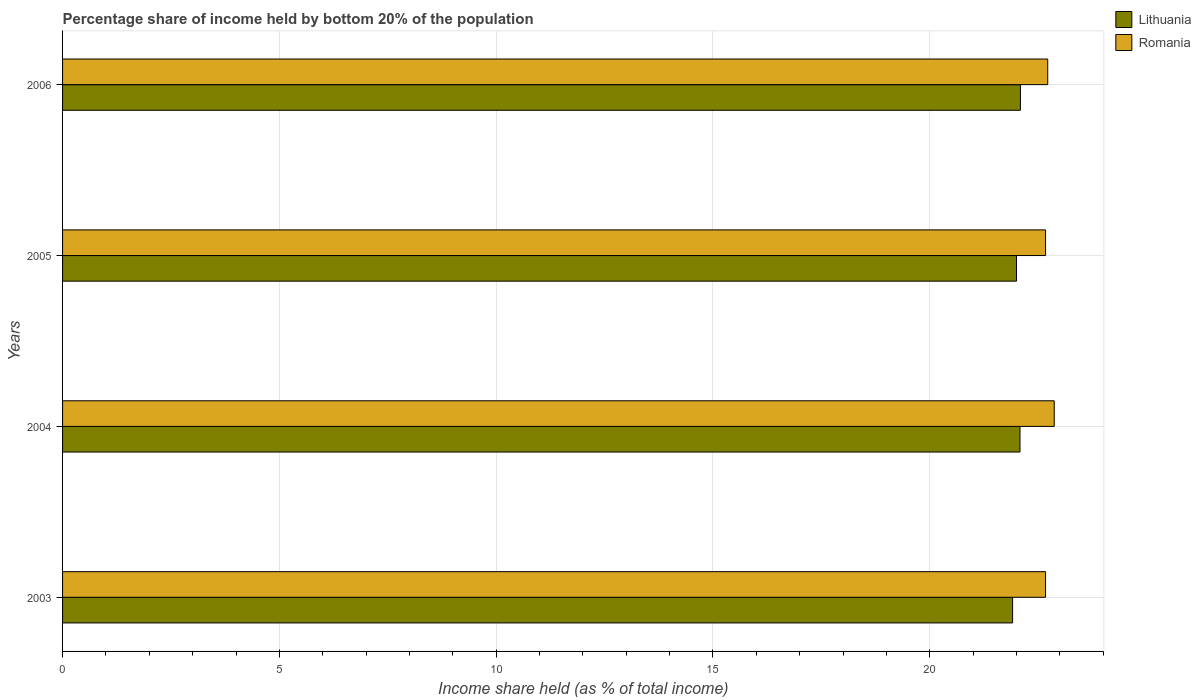Are the number of bars per tick equal to the number of legend labels?
Offer a terse response. Yes. Are the number of bars on each tick of the Y-axis equal?
Provide a succinct answer. Yes. How many bars are there on the 4th tick from the top?
Your response must be concise. 2. What is the share of income held by bottom 20% of the population in Romania in 2004?
Ensure brevity in your answer.  22.87. Across all years, what is the maximum share of income held by bottom 20% of the population in Romania?
Provide a succinct answer. 22.87. Across all years, what is the minimum share of income held by bottom 20% of the population in Romania?
Your answer should be very brief. 22.67. In which year was the share of income held by bottom 20% of the population in Lithuania maximum?
Offer a very short reply. 2006. In which year was the share of income held by bottom 20% of the population in Romania minimum?
Offer a terse response. 2003. What is the total share of income held by bottom 20% of the population in Lithuania in the graph?
Offer a terse response. 88.08. What is the difference between the share of income held by bottom 20% of the population in Lithuania in 2003 and that in 2006?
Offer a very short reply. -0.18. What is the difference between the share of income held by bottom 20% of the population in Romania in 2004 and the share of income held by bottom 20% of the population in Lithuania in 2006?
Give a very brief answer. 0.78. What is the average share of income held by bottom 20% of the population in Romania per year?
Your answer should be compact. 22.73. In the year 2003, what is the difference between the share of income held by bottom 20% of the population in Lithuania and share of income held by bottom 20% of the population in Romania?
Your answer should be very brief. -0.76. In how many years, is the share of income held by bottom 20% of the population in Lithuania greater than 1 %?
Your answer should be compact. 4. What is the ratio of the share of income held by bottom 20% of the population in Romania in 2005 to that in 2006?
Make the answer very short. 1. What is the difference between the highest and the second highest share of income held by bottom 20% of the population in Romania?
Give a very brief answer. 0.15. What is the difference between the highest and the lowest share of income held by bottom 20% of the population in Lithuania?
Provide a short and direct response. 0.18. In how many years, is the share of income held by bottom 20% of the population in Lithuania greater than the average share of income held by bottom 20% of the population in Lithuania taken over all years?
Keep it short and to the point. 2. What does the 1st bar from the top in 2004 represents?
Offer a very short reply. Romania. What does the 2nd bar from the bottom in 2005 represents?
Ensure brevity in your answer.  Romania. How many years are there in the graph?
Provide a short and direct response. 4. Are the values on the major ticks of X-axis written in scientific E-notation?
Keep it short and to the point. No. Does the graph contain any zero values?
Provide a succinct answer. No. Where does the legend appear in the graph?
Your response must be concise. Top right. How many legend labels are there?
Make the answer very short. 2. How are the legend labels stacked?
Offer a terse response. Vertical. What is the title of the graph?
Offer a terse response. Percentage share of income held by bottom 20% of the population. Does "Maldives" appear as one of the legend labels in the graph?
Offer a terse response. No. What is the label or title of the X-axis?
Offer a very short reply. Income share held (as % of total income). What is the Income share held (as % of total income) of Lithuania in 2003?
Keep it short and to the point. 21.91. What is the Income share held (as % of total income) in Romania in 2003?
Make the answer very short. 22.67. What is the Income share held (as % of total income) of Lithuania in 2004?
Provide a succinct answer. 22.08. What is the Income share held (as % of total income) in Romania in 2004?
Offer a very short reply. 22.87. What is the Income share held (as % of total income) in Lithuania in 2005?
Keep it short and to the point. 22. What is the Income share held (as % of total income) in Romania in 2005?
Your response must be concise. 22.67. What is the Income share held (as % of total income) in Lithuania in 2006?
Offer a very short reply. 22.09. What is the Income share held (as % of total income) in Romania in 2006?
Provide a succinct answer. 22.72. Across all years, what is the maximum Income share held (as % of total income) of Lithuania?
Offer a terse response. 22.09. Across all years, what is the maximum Income share held (as % of total income) in Romania?
Ensure brevity in your answer.  22.87. Across all years, what is the minimum Income share held (as % of total income) of Lithuania?
Make the answer very short. 21.91. Across all years, what is the minimum Income share held (as % of total income) of Romania?
Offer a very short reply. 22.67. What is the total Income share held (as % of total income) in Lithuania in the graph?
Provide a short and direct response. 88.08. What is the total Income share held (as % of total income) of Romania in the graph?
Ensure brevity in your answer.  90.93. What is the difference between the Income share held (as % of total income) in Lithuania in 2003 and that in 2004?
Offer a terse response. -0.17. What is the difference between the Income share held (as % of total income) of Lithuania in 2003 and that in 2005?
Ensure brevity in your answer.  -0.09. What is the difference between the Income share held (as % of total income) of Lithuania in 2003 and that in 2006?
Ensure brevity in your answer.  -0.18. What is the difference between the Income share held (as % of total income) of Lithuania in 2004 and that in 2005?
Make the answer very short. 0.08. What is the difference between the Income share held (as % of total income) in Romania in 2004 and that in 2005?
Keep it short and to the point. 0.2. What is the difference between the Income share held (as % of total income) of Lithuania in 2004 and that in 2006?
Your answer should be compact. -0.01. What is the difference between the Income share held (as % of total income) in Romania in 2004 and that in 2006?
Ensure brevity in your answer.  0.15. What is the difference between the Income share held (as % of total income) in Lithuania in 2005 and that in 2006?
Offer a terse response. -0.09. What is the difference between the Income share held (as % of total income) in Romania in 2005 and that in 2006?
Provide a short and direct response. -0.05. What is the difference between the Income share held (as % of total income) of Lithuania in 2003 and the Income share held (as % of total income) of Romania in 2004?
Offer a terse response. -0.96. What is the difference between the Income share held (as % of total income) of Lithuania in 2003 and the Income share held (as % of total income) of Romania in 2005?
Ensure brevity in your answer.  -0.76. What is the difference between the Income share held (as % of total income) in Lithuania in 2003 and the Income share held (as % of total income) in Romania in 2006?
Your answer should be very brief. -0.81. What is the difference between the Income share held (as % of total income) of Lithuania in 2004 and the Income share held (as % of total income) of Romania in 2005?
Offer a terse response. -0.59. What is the difference between the Income share held (as % of total income) in Lithuania in 2004 and the Income share held (as % of total income) in Romania in 2006?
Your response must be concise. -0.64. What is the difference between the Income share held (as % of total income) in Lithuania in 2005 and the Income share held (as % of total income) in Romania in 2006?
Your response must be concise. -0.72. What is the average Income share held (as % of total income) of Lithuania per year?
Give a very brief answer. 22.02. What is the average Income share held (as % of total income) of Romania per year?
Make the answer very short. 22.73. In the year 2003, what is the difference between the Income share held (as % of total income) in Lithuania and Income share held (as % of total income) in Romania?
Offer a very short reply. -0.76. In the year 2004, what is the difference between the Income share held (as % of total income) in Lithuania and Income share held (as % of total income) in Romania?
Offer a terse response. -0.79. In the year 2005, what is the difference between the Income share held (as % of total income) of Lithuania and Income share held (as % of total income) of Romania?
Your answer should be compact. -0.67. In the year 2006, what is the difference between the Income share held (as % of total income) in Lithuania and Income share held (as % of total income) in Romania?
Your answer should be very brief. -0.63. What is the ratio of the Income share held (as % of total income) of Romania in 2003 to that in 2004?
Offer a very short reply. 0.99. What is the ratio of the Income share held (as % of total income) in Lithuania in 2003 to that in 2005?
Your answer should be compact. 1. What is the ratio of the Income share held (as % of total income) in Romania in 2003 to that in 2006?
Give a very brief answer. 1. What is the ratio of the Income share held (as % of total income) of Romania in 2004 to that in 2005?
Ensure brevity in your answer.  1.01. What is the ratio of the Income share held (as % of total income) in Lithuania in 2004 to that in 2006?
Offer a very short reply. 1. What is the ratio of the Income share held (as % of total income) in Romania in 2004 to that in 2006?
Make the answer very short. 1.01. What is the difference between the highest and the lowest Income share held (as % of total income) of Lithuania?
Your response must be concise. 0.18. 